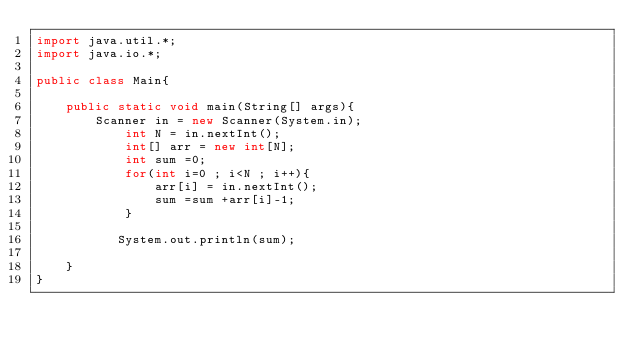<code> <loc_0><loc_0><loc_500><loc_500><_Java_>import java.util.*;
import java.io.*;

public class Main{

    public static void main(String[] args){
        Scanner in = new Scanner(System.in);
            int N = in.nextInt();
            int[] arr = new int[N];
            int sum =0;
            for(int i=0 ; i<N ; i++){
                arr[i] = in.nextInt();
                sum =sum +arr[i]-1;
            }
            
           System.out.println(sum);
        
    }
}</code> 